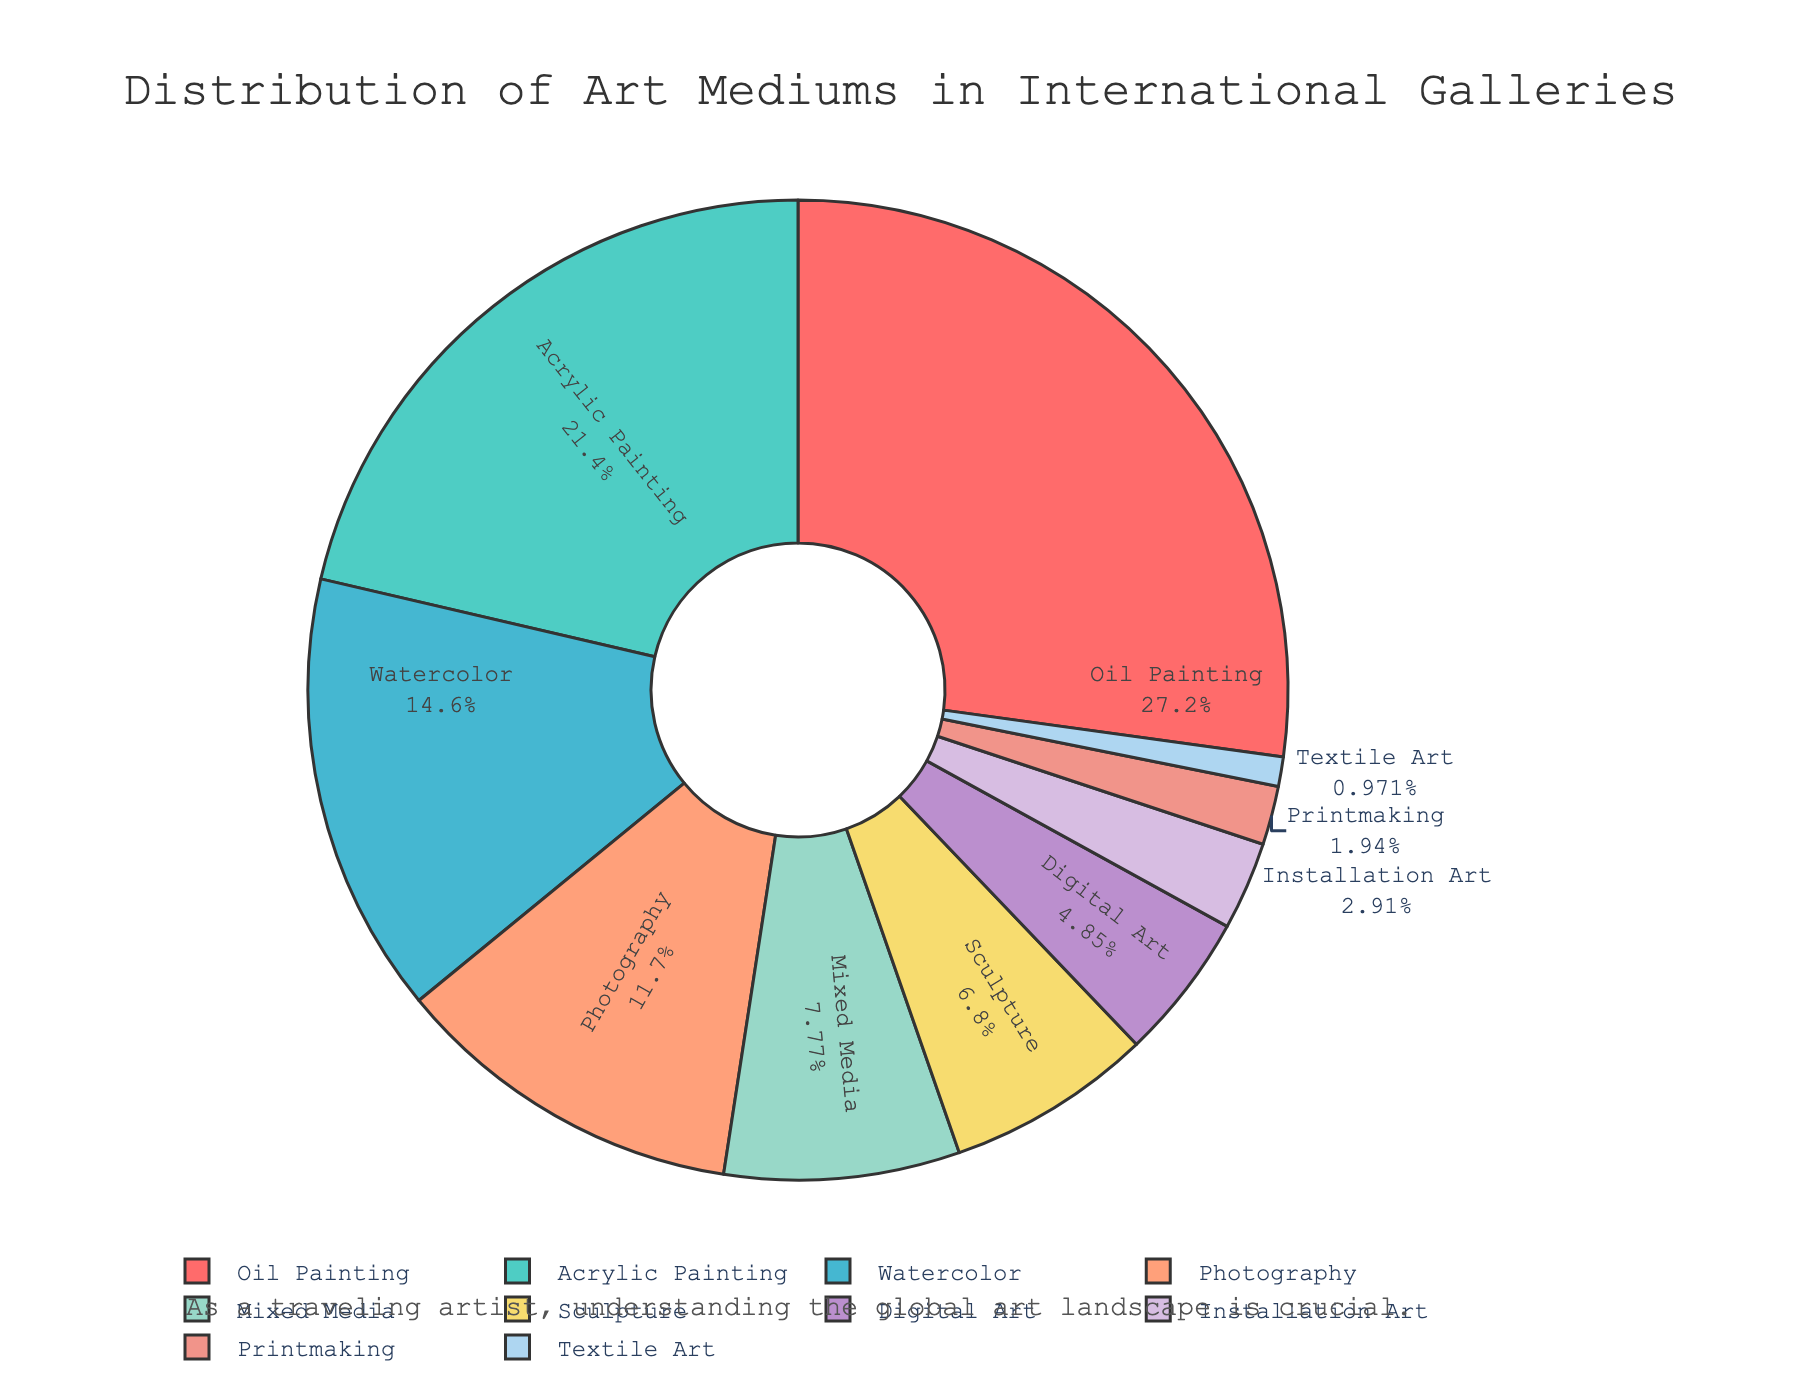Which medium occupies the largest segment of the pie chart? Upon observing the pie chart, the 'Oil Painting' segment appears to be the largest. This is likely due to its higher percentage value compared to other mediums.
Answer: Oil Painting What is the total percentage occupied by traditional painting mediums (Oil Painting, Acrylic Painting, Watercolor)? Summing up the percentages of Oil Painting (28%), Acrylic Painting (22%), and Watercolor (15%) gives us 28 + 22 + 15 = 65%.
Answer: 65% Is the proportion of Mixed Media greater than that of Sculpture? According to the chart, the percentage for Mixed Media is 8%, while for Sculpture, it is 7%. Therefore, Mixed Media has a greater proportion than Sculpture.
Answer: Yes Which art medium has the smallest representation in international galleries? Examining the chart, 'Textile Art' has the smallest segment, indicating it has the lowest percentage.
Answer: Textile Art By how much does the percentage of Photography exceed that of Installation Art? Photography has a percentage of 12% and Installation Art has 3%. Subtract the latter from the former to find the difference: 12 - 3 = 9%.
Answer: 9% Which medium uses a shaded tone closest to blue? Looking at the colors, the closest to blue appears in the 'Digital Art' segment, which is shaded close to blue.
Answer: Digital Art What is the combined percentage of all non-painting mediums? Summing the percentages of Photography (12%), Mixed Media (8%), Sculpture (7%), Digital Art (5%), Installation Art (3%), Printmaking (2%), and Textile Art (1%) gives us 12 + 8 + 7 + 5 + 3 + 2 + 1 = 38%.
Answer: 38% Which has a larger representation: Digital Art or Textile Art? According to the chart, Digital Art has a percentage of 5% while Textile Art has only 1%. Thus, Digital Art has a larger representation.
Answer: Digital Art If you combine the percentages of all painting-related art forms, is that more than 50%? Adding the percentages of Oil Painting (28%), Acrylic Painting (22%), and Watercolor (15%) gives 65%, which is more than 50%.
Answer: Yes Which art mediums together make up less than 10% of the chart? Adding the percentages of Textile Art (1%), Printmaking (2%), and Installation Art (3%), we get 1 + 2 + 3 = 6%, which is less than 10%.
Answer: Textile Art, Printmaking, Installation Art 